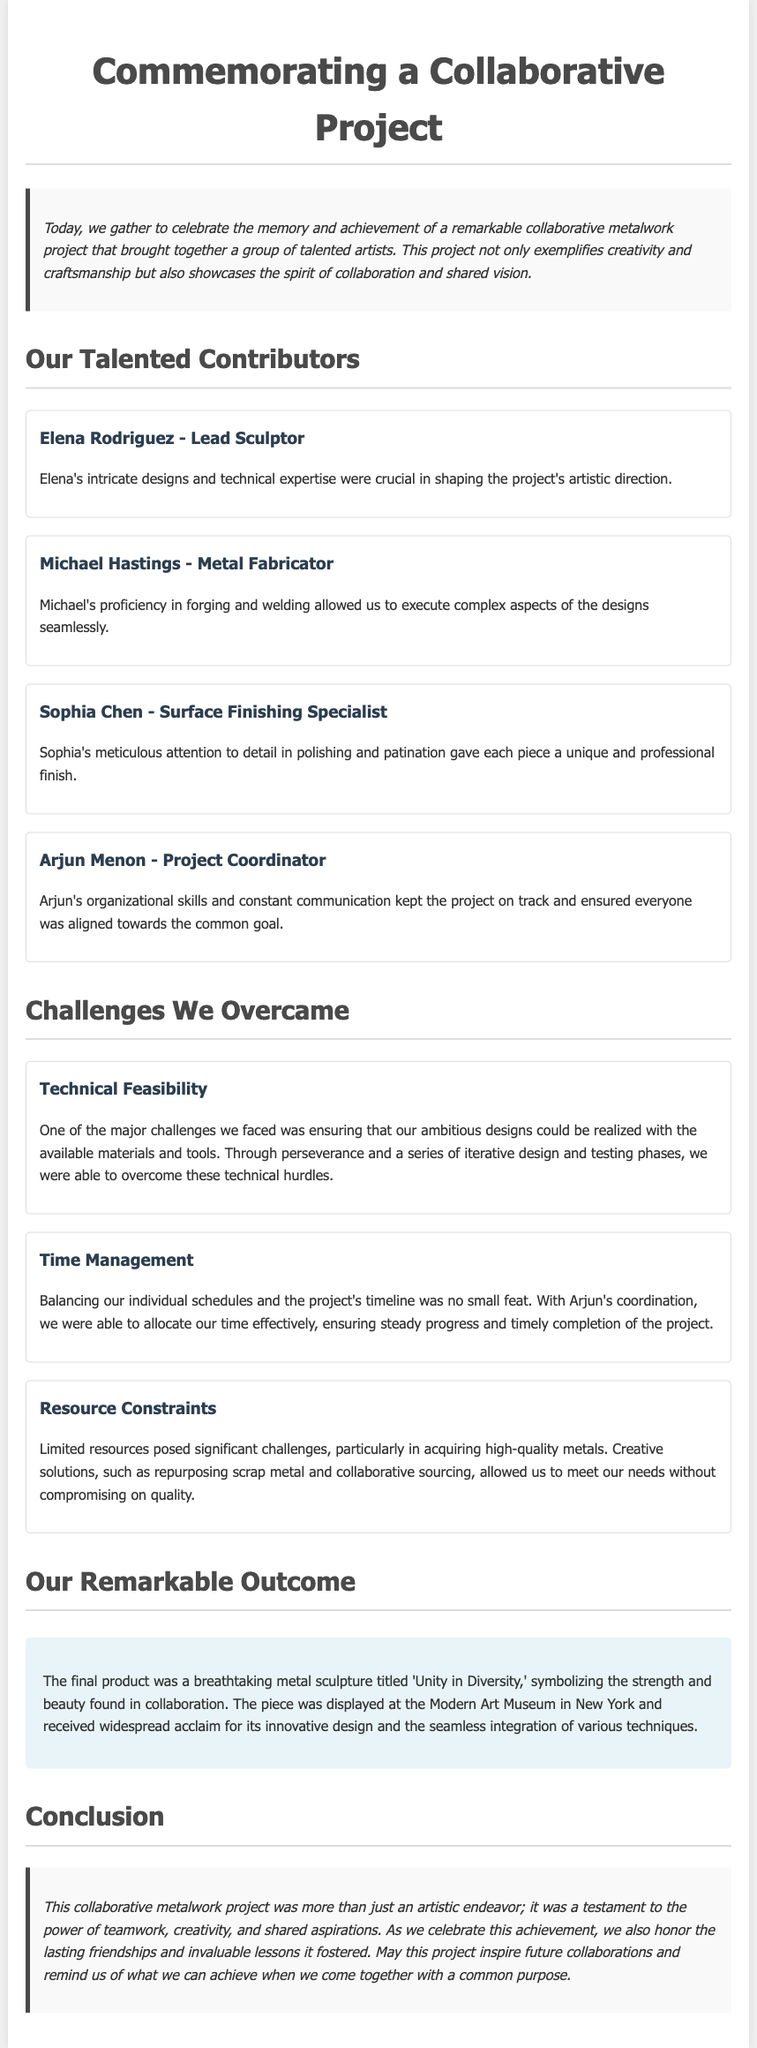What was the title of the final sculpture? The document states that the final product was a metal sculpture titled 'Unity in Diversity.'
Answer: 'Unity in Diversity' Who was the project coordinator? The document lists Arjun Menon as the Project Coordinator.
Answer: Arjun Menon How many main challenges are mentioned? There are three challenges outlined in the document: Technical Feasibility, Time Management, and Resource Constraints.
Answer: Three What was Elena Rodriguez’s role? The document specifies that Elena Rodriguez was the Lead Sculptor.
Answer: Lead Sculptor Which museum displayed the final sculpture? According to the document, the final sculpture was displayed at the Modern Art Museum in New York.
Answer: Modern Art Museum What theme does the sculpture represent? The document mentions that the sculpture symbolizes the strength and beauty found in collaboration.
Answer: Strength and beauty in collaboration What did the artists prioritize during their collaboration? The eulogy highlights that teamwork, creativity, and shared aspirations were critical during the collaboration.
Answer: Teamwork, creativity, and shared aspirations How did the team overcome limited resources? The document describes that they used creative solutions such as repurposing scrap metal and collaborative sourcing.
Answer: Repurposing scrap metal and collaborative sourcing 